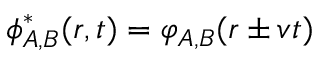<formula> <loc_0><loc_0><loc_500><loc_500>{ \phi } _ { A , B } ^ { * } ( r , t ) = \varphi _ { A , B } ( r \pm \mathfrak { v } t )</formula> 